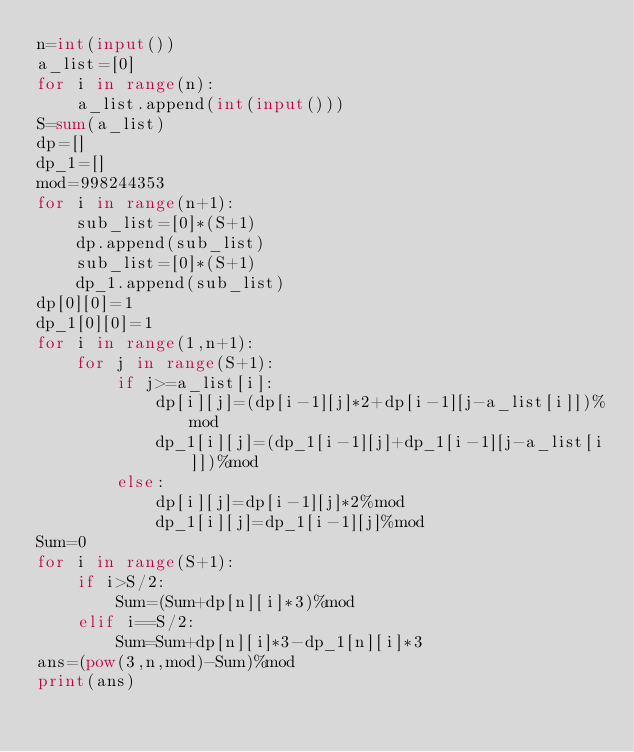Convert code to text. <code><loc_0><loc_0><loc_500><loc_500><_Python_>n=int(input())
a_list=[0]
for i in range(n):
    a_list.append(int(input()))
S=sum(a_list)
dp=[]
dp_1=[]
mod=998244353
for i in range(n+1):
    sub_list=[0]*(S+1)
    dp.append(sub_list)
    sub_list=[0]*(S+1)
    dp_1.append(sub_list)
dp[0][0]=1
dp_1[0][0]=1
for i in range(1,n+1):
    for j in range(S+1):
        if j>=a_list[i]:
            dp[i][j]=(dp[i-1][j]*2+dp[i-1][j-a_list[i]])%mod
            dp_1[i][j]=(dp_1[i-1][j]+dp_1[i-1][j-a_list[i]])%mod
        else:
            dp[i][j]=dp[i-1][j]*2%mod
            dp_1[i][j]=dp_1[i-1][j]%mod
Sum=0
for i in range(S+1):
    if i>S/2:
        Sum=(Sum+dp[n][i]*3)%mod
    elif i==S/2:
        Sum=Sum+dp[n][i]*3-dp_1[n][i]*3
ans=(pow(3,n,mod)-Sum)%mod
print(ans)

</code> 